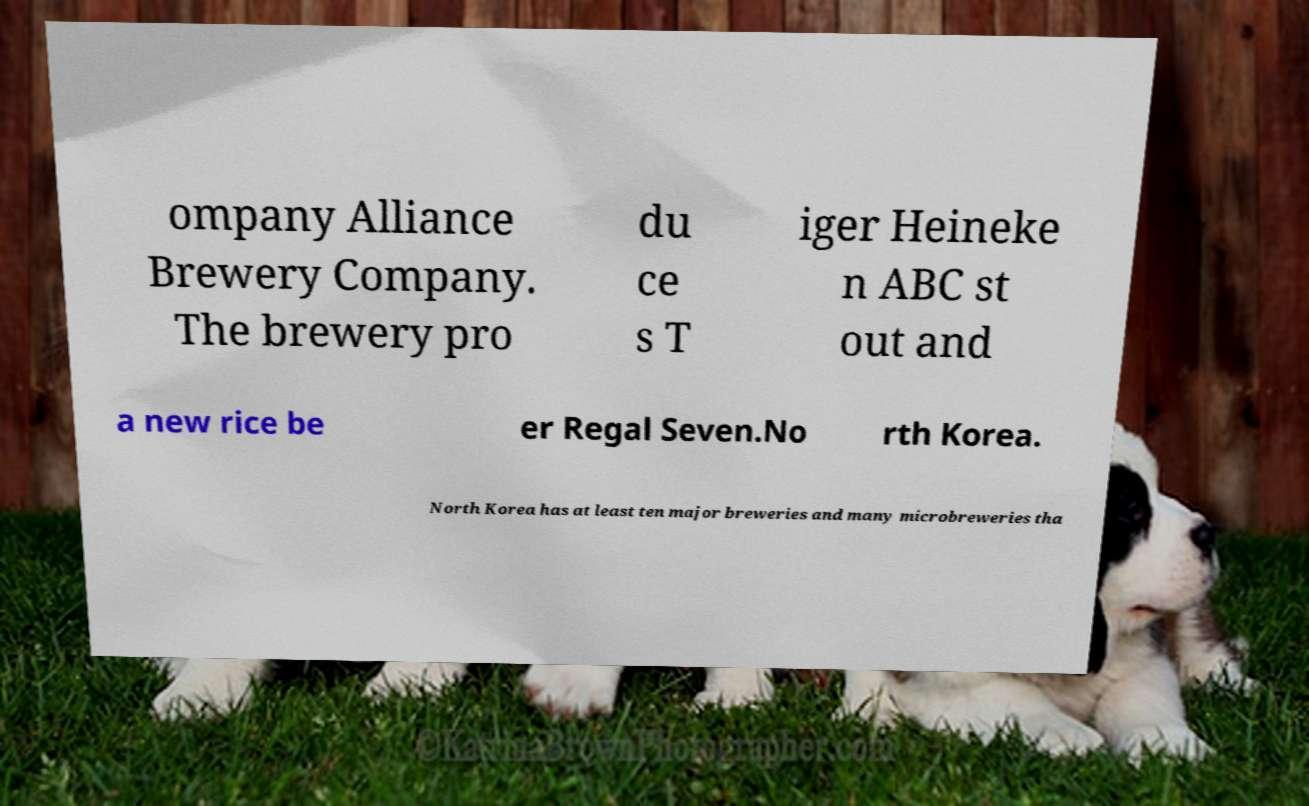Could you assist in decoding the text presented in this image and type it out clearly? ompany Alliance Brewery Company. The brewery pro du ce s T iger Heineke n ABC st out and a new rice be er Regal Seven.No rth Korea. North Korea has at least ten major breweries and many microbreweries tha 